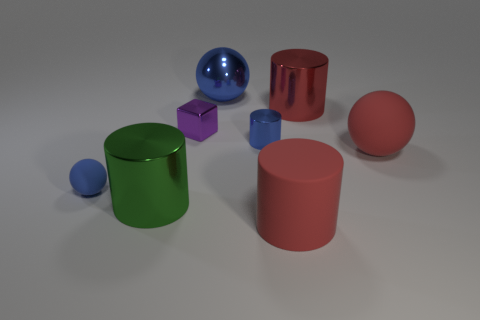What number of other things are there of the same color as the small sphere?
Make the answer very short. 2. Does the big red object that is in front of the small sphere have the same material as the tiny blue thing left of the large green object?
Make the answer very short. Yes. What size is the ball that is on the right side of the shiny ball?
Offer a very short reply. Large. What is the material of the big red object that is the same shape as the tiny blue rubber thing?
Offer a very short reply. Rubber. What is the shape of the red rubber object that is behind the tiny blue matte sphere?
Make the answer very short. Sphere. How many tiny blue metallic objects are the same shape as the green metallic thing?
Keep it short and to the point. 1. Is the number of green metal cylinders that are behind the blue cylinder the same as the number of big cylinders that are behind the blue matte object?
Offer a terse response. No. Is there a purple block that has the same material as the large red ball?
Make the answer very short. No. Does the green object have the same material as the red ball?
Offer a very short reply. No. What number of purple things are either tiny things or big balls?
Your answer should be compact. 1. 